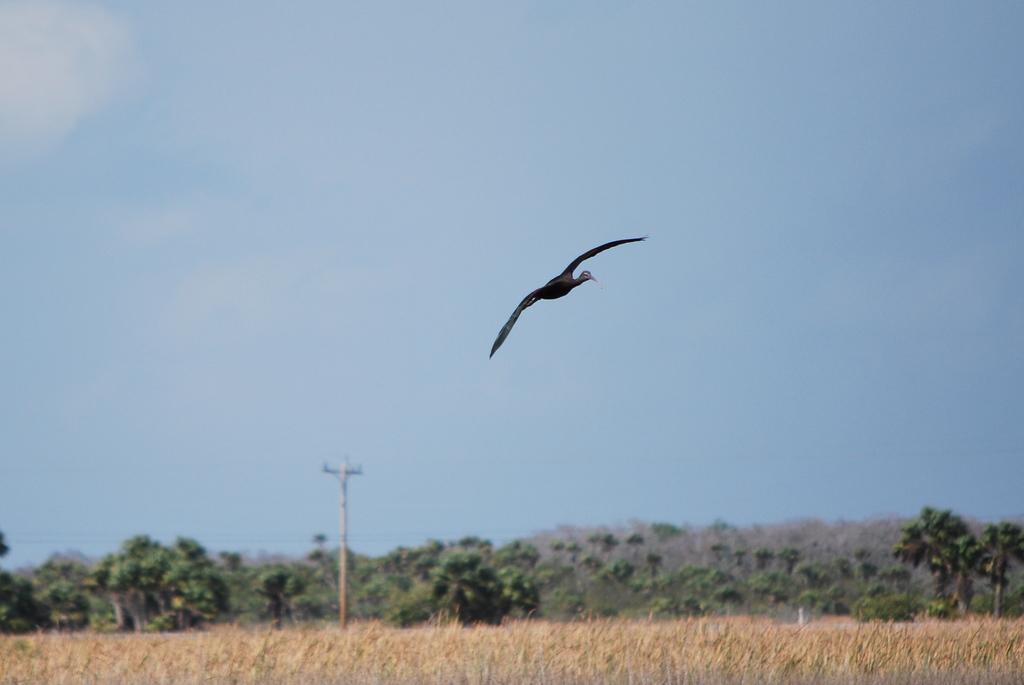Describe this image in one or two sentences. In this image we can see the bird flying in the sky. Here we can see the farm field. Here we can see the electric pole and here we can see the electric wires. In the background, we can see the trees. This is a sky with clouds. 